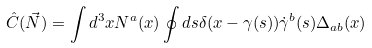Convert formula to latex. <formula><loc_0><loc_0><loc_500><loc_500>\hat { C } ( \vec { N } ) = \int d ^ { 3 } x N ^ { a } ( x ) \oint d s \delta ( x - \gamma ( s ) ) \dot { \gamma } ^ { b } ( s ) \Delta _ { a b } ( x )</formula> 